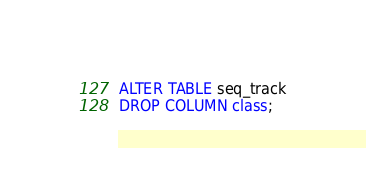<code> <loc_0><loc_0><loc_500><loc_500><_SQL_>ALTER TABLE seq_track
DROP COLUMN class;
</code> 